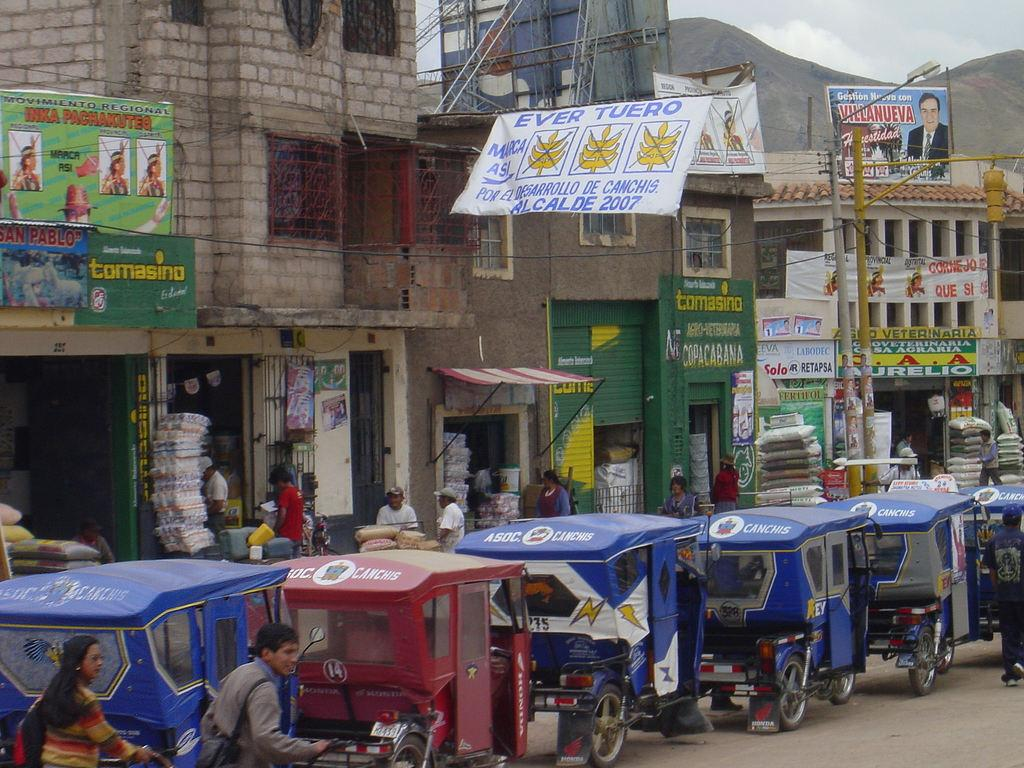Where was the image taken? The image was taken on a street. What can be seen in the background of the image? There are buildings with stores in the background. What mode of transportation is present on the road in the image? Rickshaws are present on the road in front of the buildings. What theory is being discussed by the people inside the door in the image? There is no door or people discussing a theory present in the image. 